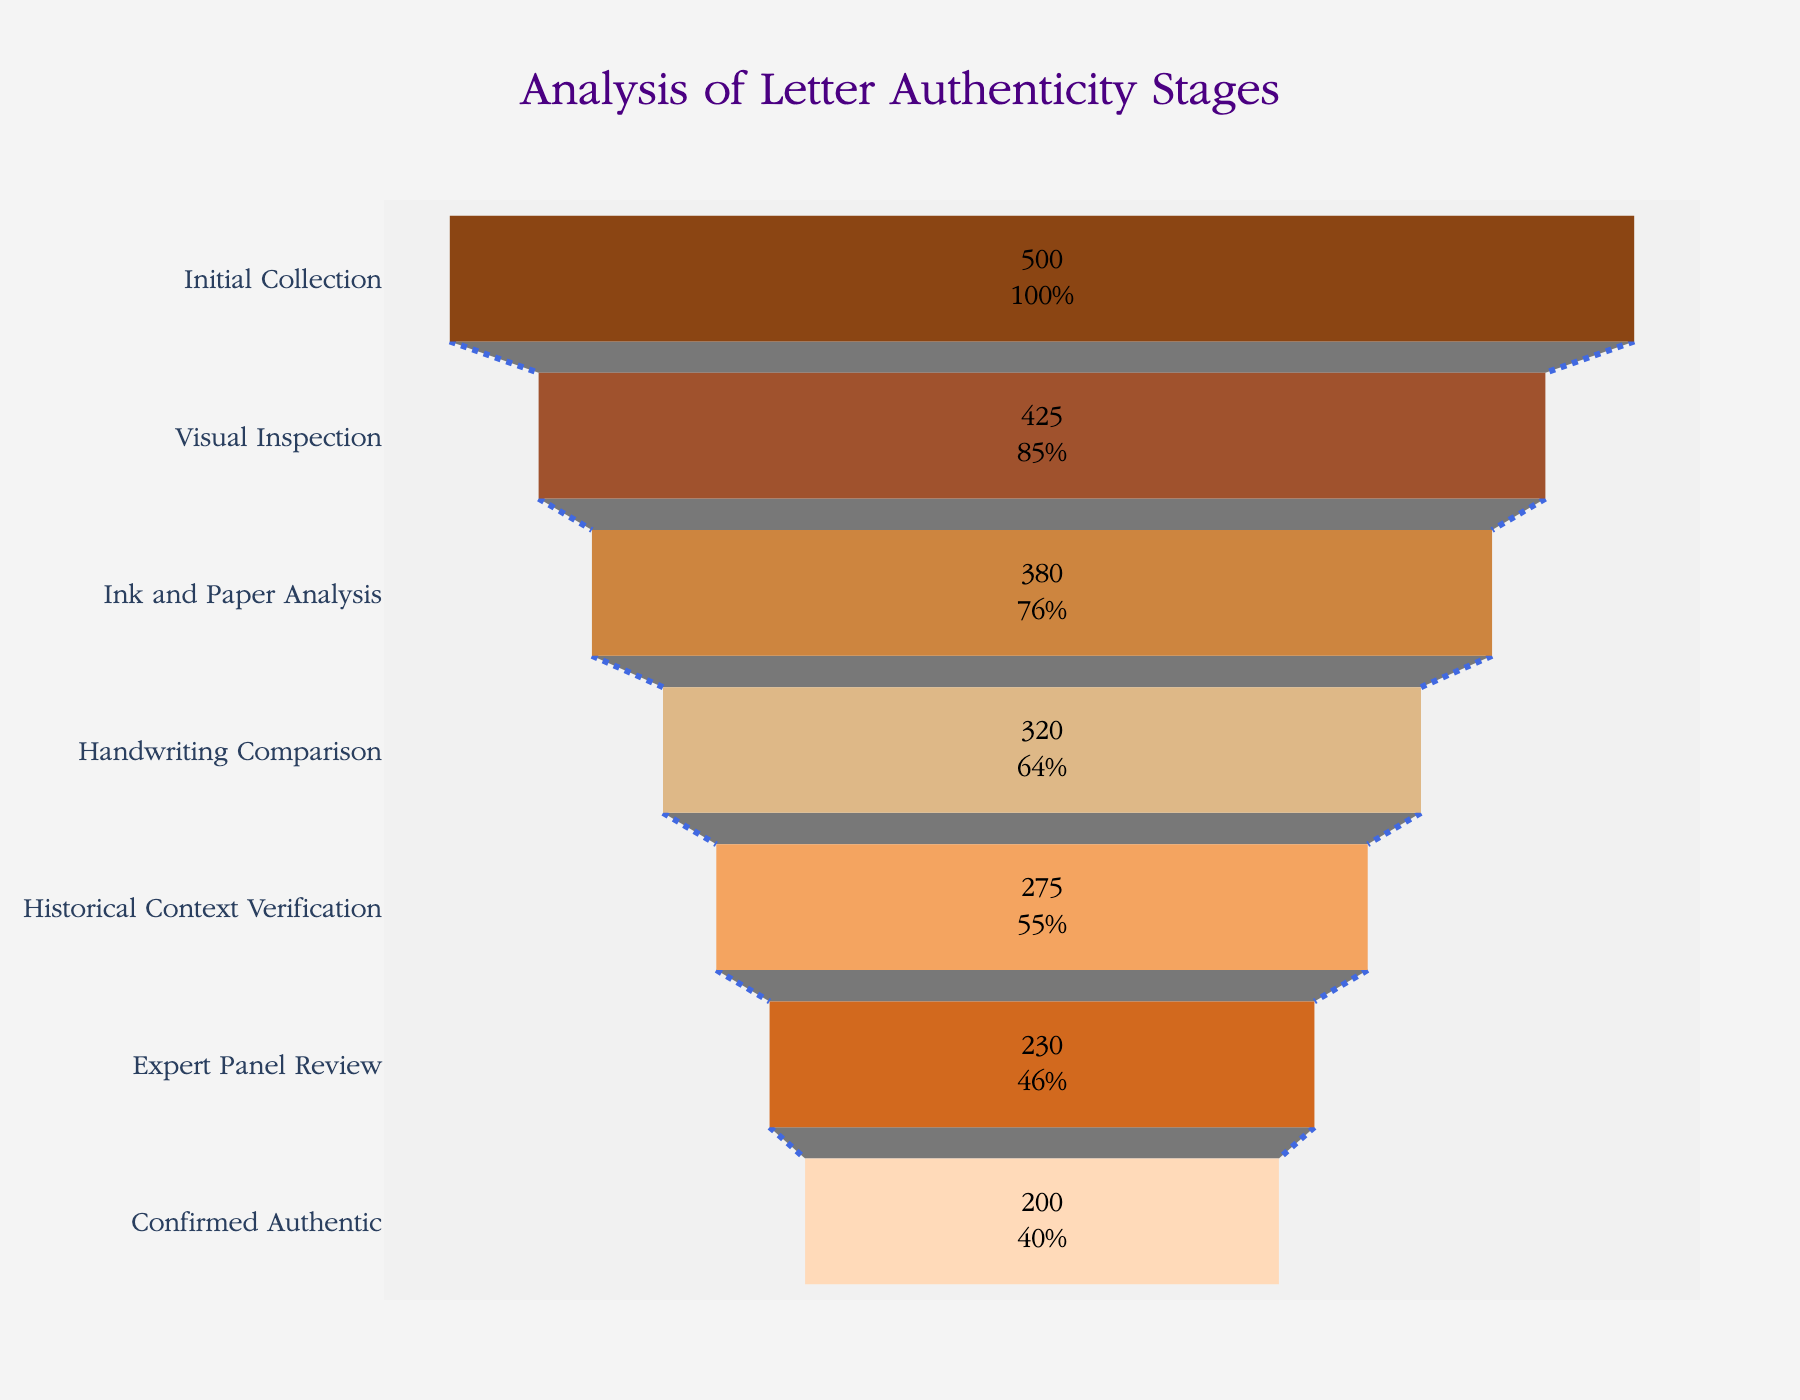What is the title of the funnel chart? The chart's title is displayed prominently at the top center of the figure. It reads "Analysis of Letter Authenticity Stages."
Answer: Analysis of Letter Authenticity Stages How many letters were initially collected? The figure shows the first stage, labeled "Initial Collection," with a corresponding bar segment indicating the number of letters. The value inside this segment is 500.
Answer: 500 At which stage do we see the sharpest decrease in the number of letters from one stage to the next? To find the sharpest decrease, we subtract the number of letters between consecutive stages and identify the largest difference. Between "Handwriting Comparison" (320) and "Historical Context Verification" (275), the difference is 45, the largest drop compared to other stages.
Answer: Handwriting Comparison to Historical Context Verification What is the final number of letters confirmed as authentic? The last stage labeled "Confirmed Authentic" displays the number of letters determined to be genuine. The figure shows 200 letters at this stage.
Answer: 200 How many letters were rejected during the expert panel review? The number of letters before "Expert Panel Review" is 275, and after is 230. The difference, representing rejected letters, is 275 - 230 = 45.
Answer: 45 What percentage of the initial letters made it to the historical context verification stage? The number of letters at the historical context verification stage is 275. To find the percentage, we divide 275 by the initial collection, 500, and multiply by 100. The calculation is (275/500) * 100 = 55%.
Answer: 55% Compare the number of letters after visual inspection and after handwriting comparison. Which stage has more letters and by how many? After visual inspection, there are 425 letters, and after handwriting comparison, there are 320 letters. The difference is 425 - 320 = 105, meaning more letters are at the visual inspection stage by 105.
Answer: Visual Inspection by 105 Which color represents the 'Ink and Paper Analysis' stage in the chart? The colors are customized and aligned with the stages sequentially. The 'Ink and Paper Analysis' stage is the third, corresponding to the third color in the list, which is "Peru."
Answer: Peru How many stages are there in total in this funnel chart? By counting the label names on the y-axis or the segmented bars in the chart, we can determine there are a total of 7 stages.
Answer: 7 Out of the letters that underwent ink and paper analysis, what fraction were subsequently excluded by handwriting comparison? The number at "Ink and Paper Analysis" is 380 and at "Handwriting Comparison" is 320. Hence, exclusions are 380 - 320 = 60. The fraction is thus 60/380, which simplifies to 3/19.
Answer: 3/19 